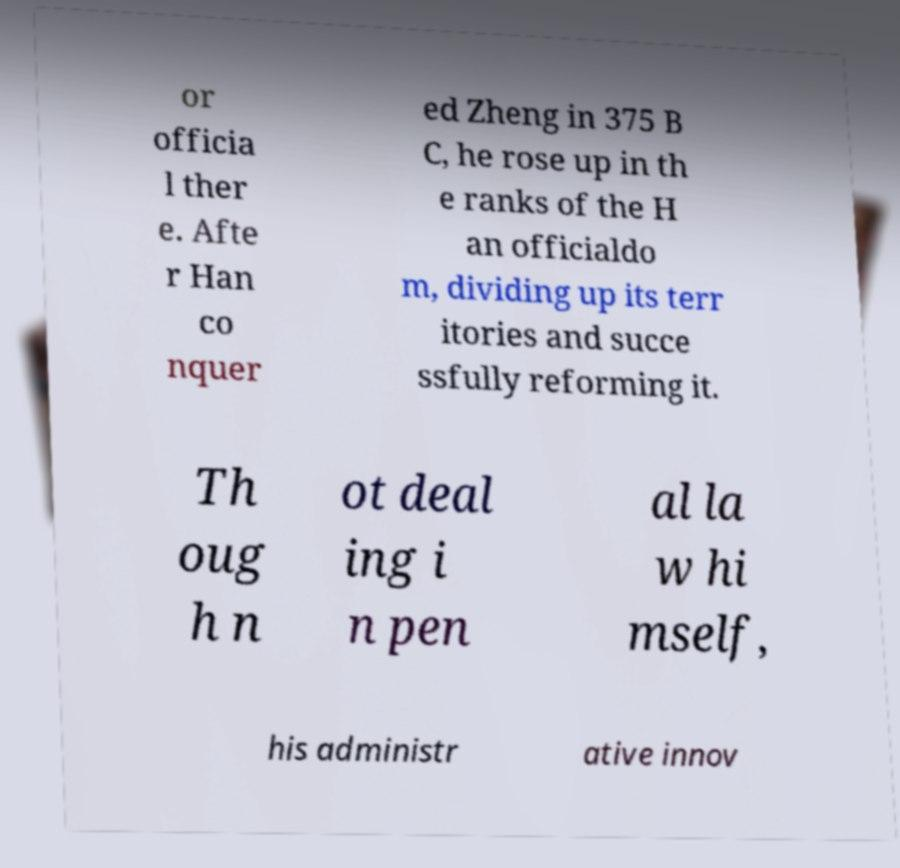Could you assist in decoding the text presented in this image and type it out clearly? or officia l ther e. Afte r Han co nquer ed Zheng in 375 B C, he rose up in th e ranks of the H an officialdo m, dividing up its terr itories and succe ssfully reforming it. Th oug h n ot deal ing i n pen al la w hi mself, his administr ative innov 